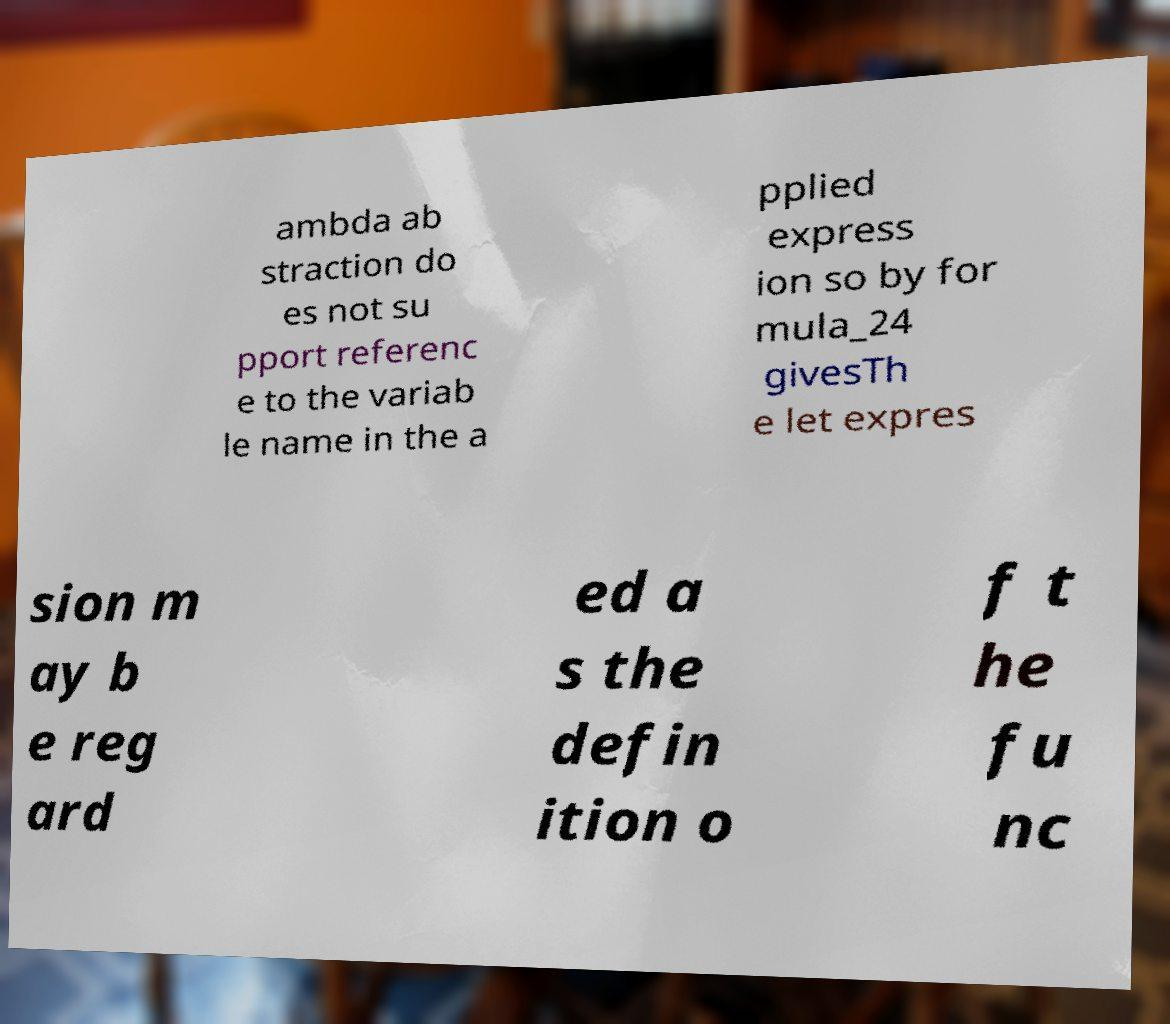Can you read and provide the text displayed in the image?This photo seems to have some interesting text. Can you extract and type it out for me? ambda ab straction do es not su pport referenc e to the variab le name in the a pplied express ion so by for mula_24 givesTh e let expres sion m ay b e reg ard ed a s the defin ition o f t he fu nc 